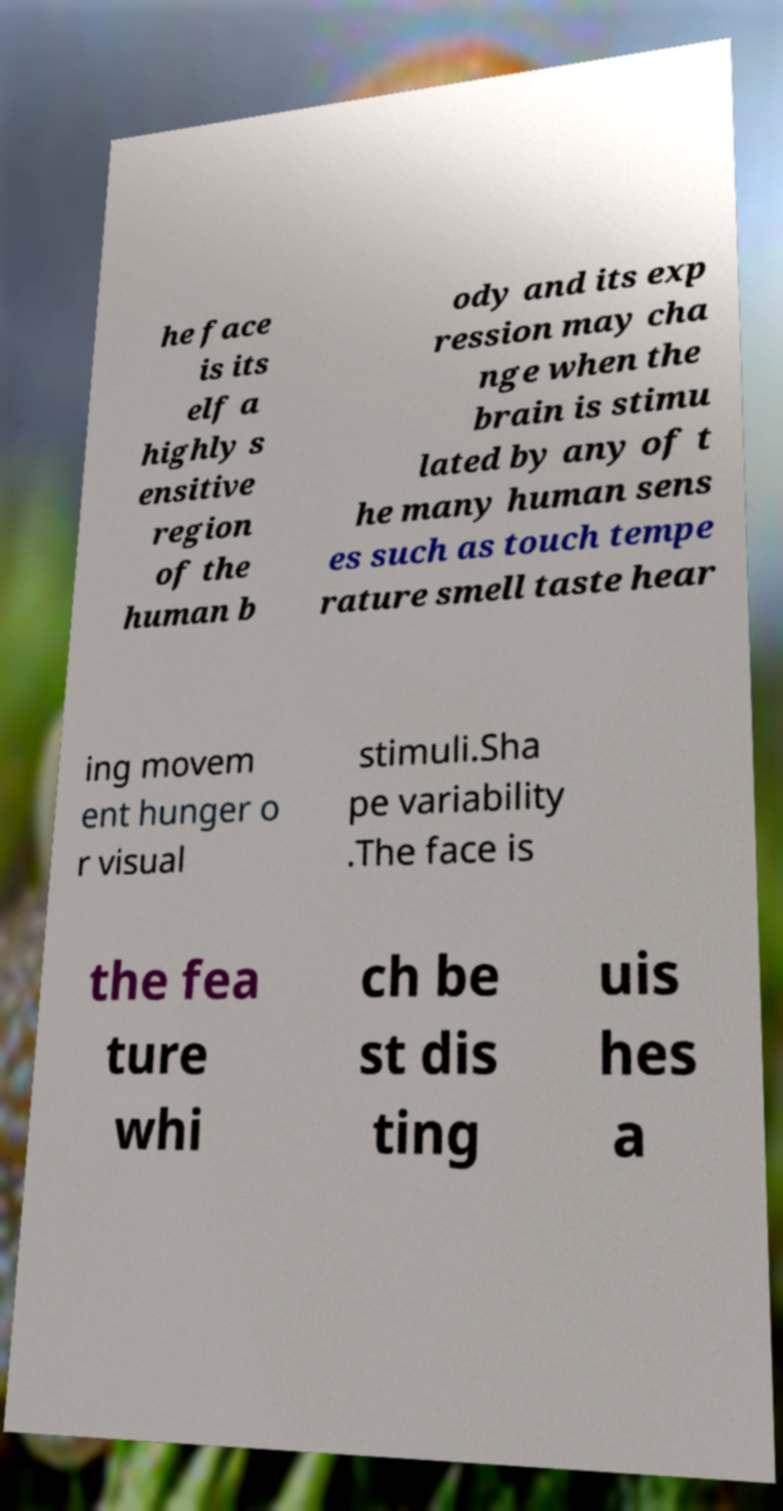Could you extract and type out the text from this image? he face is its elf a highly s ensitive region of the human b ody and its exp ression may cha nge when the brain is stimu lated by any of t he many human sens es such as touch tempe rature smell taste hear ing movem ent hunger o r visual stimuli.Sha pe variability .The face is the fea ture whi ch be st dis ting uis hes a 